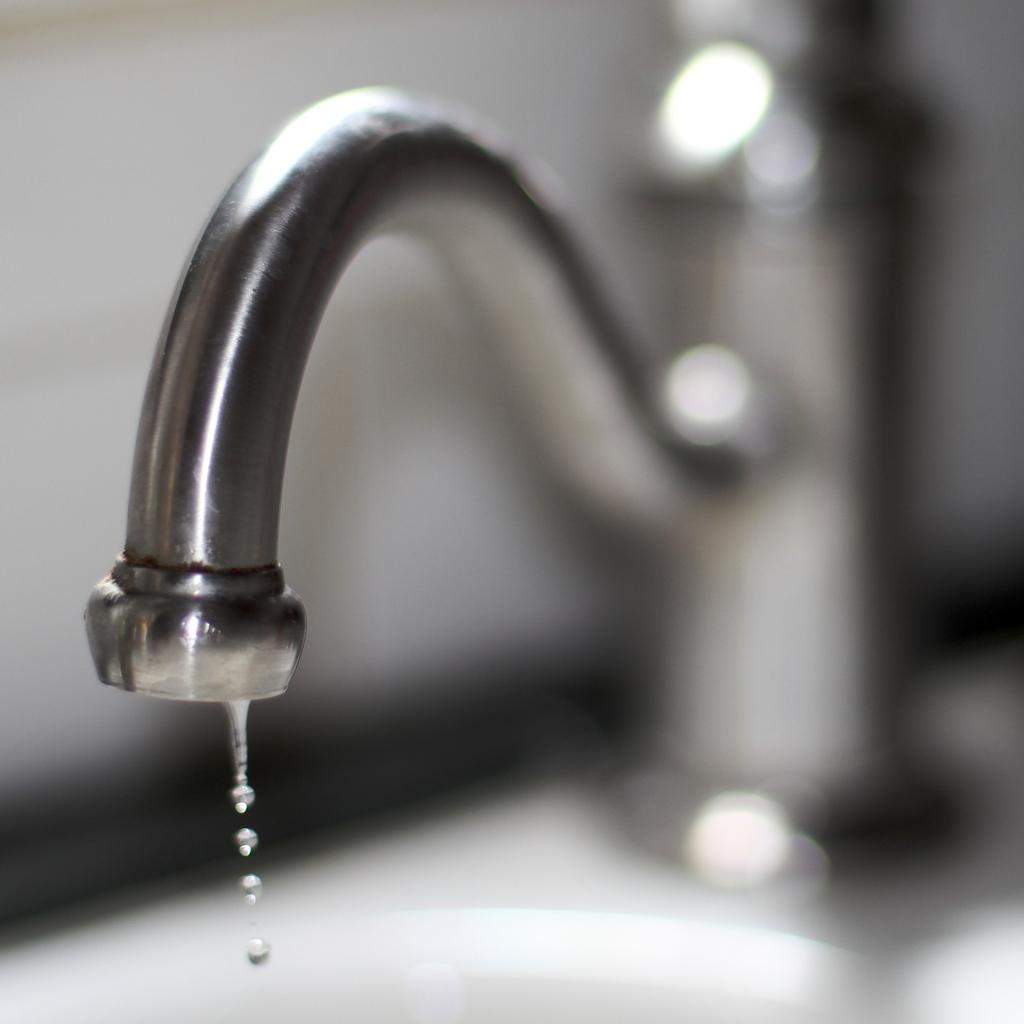What is the source of the water droplets in the image? The water droplets are coming out of a tap. Can you describe the appearance of the water droplets? The water droplets are visible in the image. What type of ring is being worn by the band in the image? There is no ring or band present in the image; it only features water droplets coming out of a tap. 